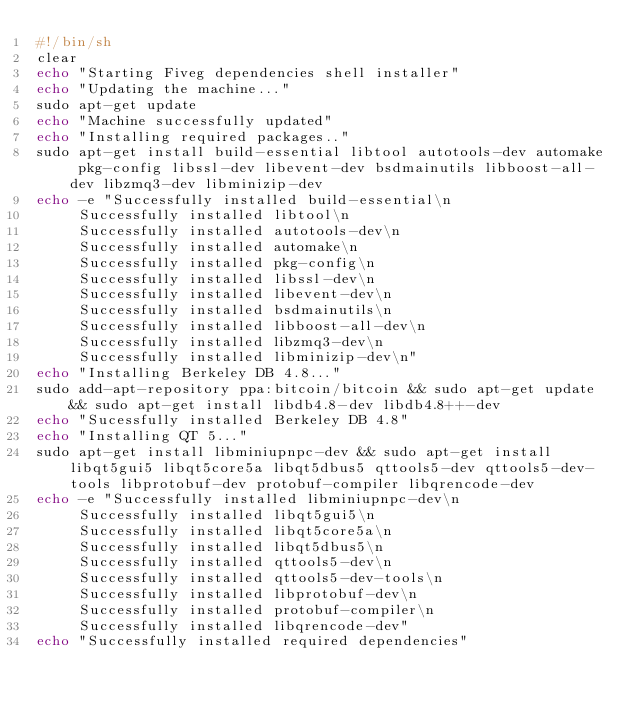<code> <loc_0><loc_0><loc_500><loc_500><_Bash_>#!/bin/sh
clear
echo "Starting Fiveg dependencies shell installer"
echo "Updating the machine..."
sudo apt-get update
echo "Machine successfully updated"
echo "Installing required packages.."
sudo apt-get install build-essential libtool autotools-dev automake pkg-config libssl-dev libevent-dev bsdmainutils libboost-all-dev libzmq3-dev libminizip-dev
echo -e "Successfully installed build-essential\n
		 Successfully installed libtool\n
		 Successfully installed autotools-dev\n
		 Successfully installed automake\n
		 Successfully installed pkg-config\n
		 Successfully installed libssl-dev\n
		 Successfully installed libevent-dev\n
		 Successfully installed bsdmainutils\n
		 Successfully installed libboost-all-dev\n
		 Successfully installed libzmq3-dev\n
		 Successfully installed libminizip-dev\n"
echo "Installing Berkeley DB 4.8..."
sudo add-apt-repository ppa:bitcoin/bitcoin && sudo apt-get update && sudo apt-get install libdb4.8-dev libdb4.8++-dev
echo "Sucessfully installed Berkeley DB 4.8"
echo "Installing QT 5..."
sudo apt-get install libminiupnpc-dev && sudo apt-get install libqt5gui5 libqt5core5a libqt5dbus5 qttools5-dev qttools5-dev-tools libprotobuf-dev protobuf-compiler libqrencode-dev
echo -e "Successfully installed libminiupnpc-dev\n
		 Successfully installed libqt5gui5\n
		 Successfully installed libqt5core5a\n
		 Successfully installed libqt5dbus5\n
		 Successfully installed qttools5-dev\n
		 Successfully installed qttools5-dev-tools\n
		 Successfully installed libprotobuf-dev\n
		 Successfully installed protobuf-compiler\n
		 Successfully installed libqrencode-dev"
echo "Successfully installed required dependencies"</code> 